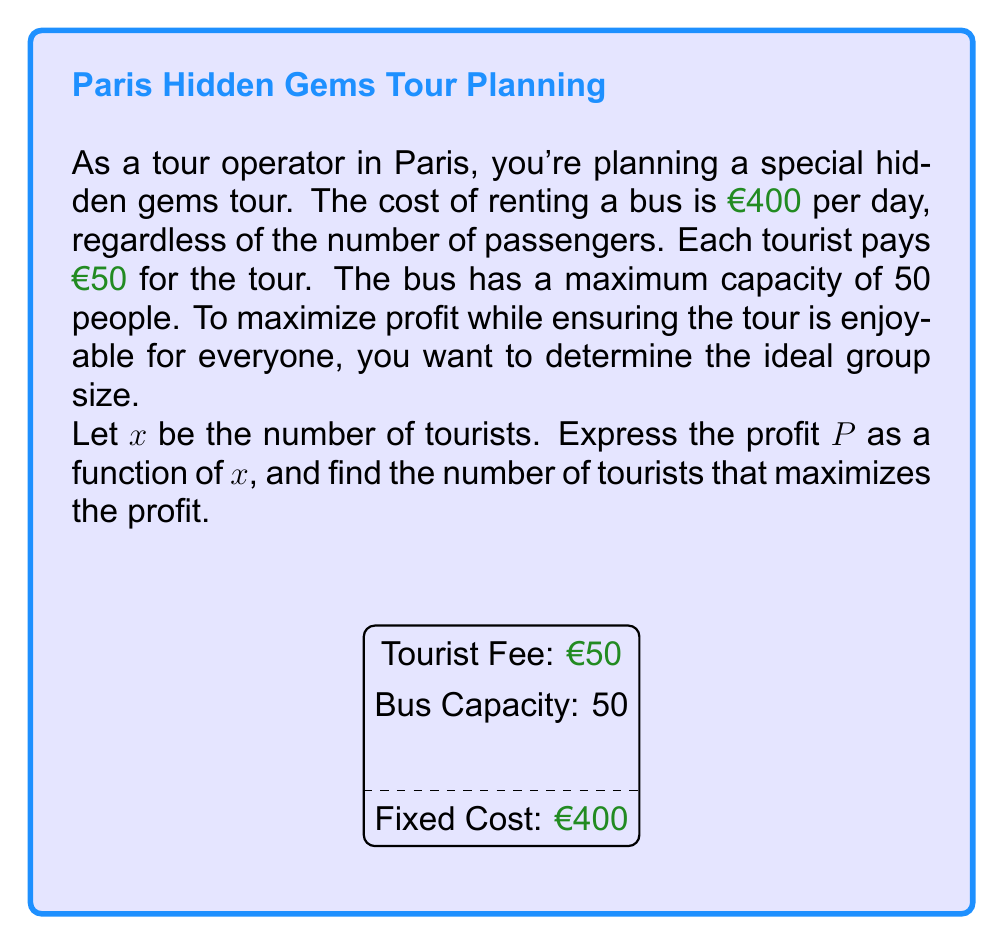What is the answer to this math problem? Let's approach this step-by-step:

1) First, we need to express the profit function:
   - Revenue: Each tourist pays €50, so for $x$ tourists, revenue is $50x$
   - Cost: The fixed cost is €400 regardless of the number of tourists
   - Profit: Revenue - Cost

   Thus, the profit function is:
   $$P(x) = 50x - 400$$

2) To find the maximum profit, we need to consider the domain restrictions:
   - The number of tourists can't be negative: $x \geq 0$
   - The bus capacity limits the maximum number of tourists: $x \leq 50$

3) Since the profit function is linear, the maximum will occur at one of the endpoints of our domain: either at $x = 0$ or $x = 50$

4) Let's evaluate the function at these points:
   $$P(0) = 50(0) - 400 = -400$$
   $$P(50) = 50(50) - 400 = 2100$$

5) Clearly, the maximum profit occurs when the bus is at full capacity: 50 tourists

6) However, we should note that the profit increases linearly with each additional tourist. In a real-world scenario, you might want to consider factors like comfort and tour quality when deciding the ideal group size.
Answer: 50 tourists 